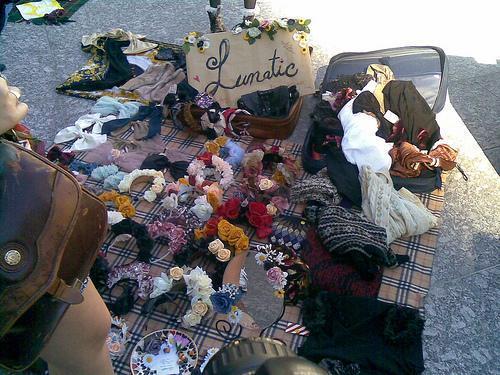How many mirrors are there?
Give a very brief answer. 1. 